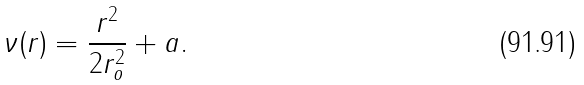<formula> <loc_0><loc_0><loc_500><loc_500>\nu ( r ) = \frac { r ^ { 2 } } { 2 r _ { o } ^ { 2 } } + a .</formula> 